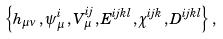<formula> <loc_0><loc_0><loc_500><loc_500>\left \{ h _ { \mu \nu } \, , \psi _ { \mu } ^ { i } \, , V _ { \mu } ^ { i j } \, , E ^ { i j k l } \, , \chi ^ { i j k } \, , D ^ { i j k l } \right \} \, ,</formula> 